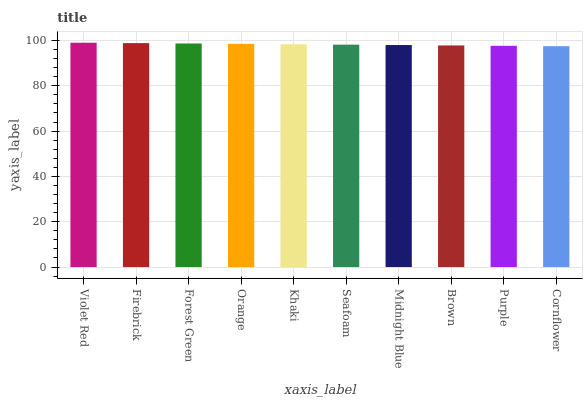Is Cornflower the minimum?
Answer yes or no. Yes. Is Violet Red the maximum?
Answer yes or no. Yes. Is Firebrick the minimum?
Answer yes or no. No. Is Firebrick the maximum?
Answer yes or no. No. Is Violet Red greater than Firebrick?
Answer yes or no. Yes. Is Firebrick less than Violet Red?
Answer yes or no. Yes. Is Firebrick greater than Violet Red?
Answer yes or no. No. Is Violet Red less than Firebrick?
Answer yes or no. No. Is Khaki the high median?
Answer yes or no. Yes. Is Seafoam the low median?
Answer yes or no. Yes. Is Seafoam the high median?
Answer yes or no. No. Is Brown the low median?
Answer yes or no. No. 